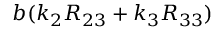Convert formula to latex. <formula><loc_0><loc_0><loc_500><loc_500>b ( k _ { 2 } R _ { 2 3 } + k _ { 3 } R _ { 3 3 } )</formula> 